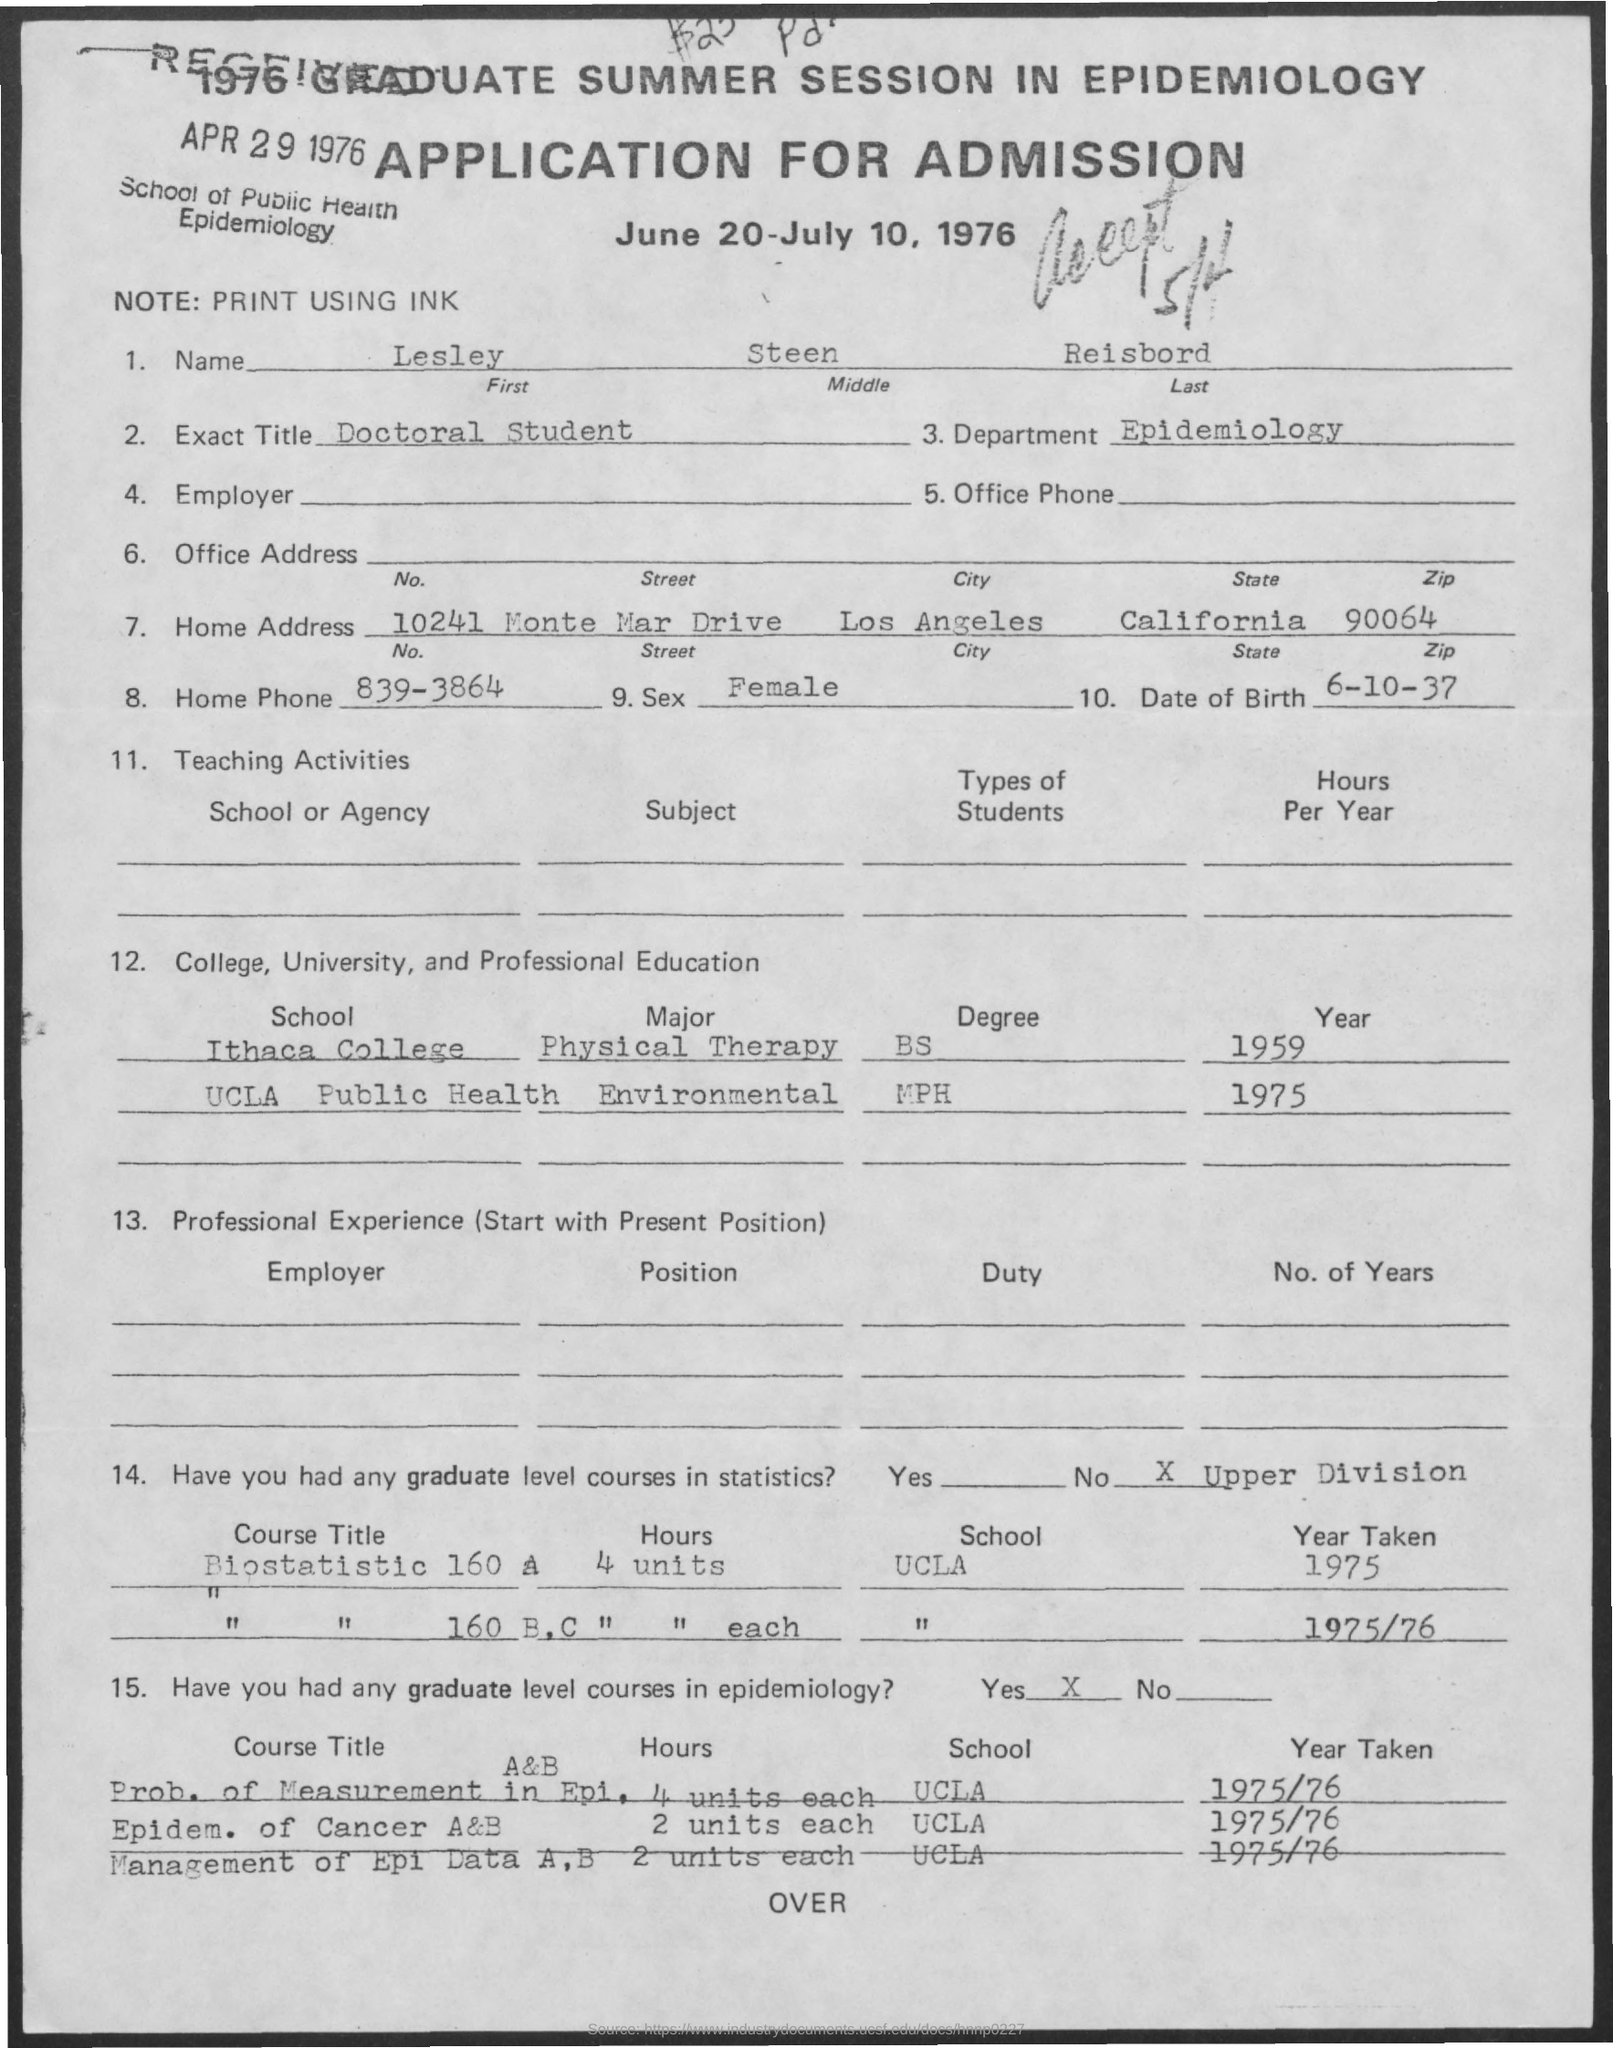On which date application was received ?
Offer a very short reply. Apr 29, 1976. What is the first name mentioned in the given application ?
Your answer should be compact. Lesley. What is the middle name as mentioned in the given application ?
Keep it short and to the point. Steen. What is the last name as mentioned in the given application ?
Provide a short and direct response. Reisbord. What is the name of the department mentioned in the given application ?
Provide a succinct answer. Epidemiology. What is the exact title mentioned in the given application ?
Make the answer very short. Doctoral Student. What is the date of birth mentioned in the given application ?
Your response must be concise. 6-10-37. What is the home phone number mentioned in the given application ?
Make the answer very short. 839-3864. What is the note mentioned in the given application ?
Ensure brevity in your answer.  Print using Ink. What is the name of the city mentioned in the home address ?
Make the answer very short. Los Angeles. 